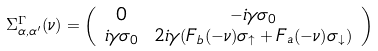Convert formula to latex. <formula><loc_0><loc_0><loc_500><loc_500>\Sigma ^ { \Gamma } _ { \alpha , \alpha ^ { \prime } } ( \nu ) & = \left ( \begin{array} { c c } 0 & - i \gamma \sigma _ { 0 } \\ i \gamma \sigma _ { 0 } & 2 i \gamma ( F _ { b } ( - \nu ) \sigma _ { \uparrow } + F _ { a } ( - \nu ) \sigma _ { \downarrow } ) \end{array} \right )</formula> 